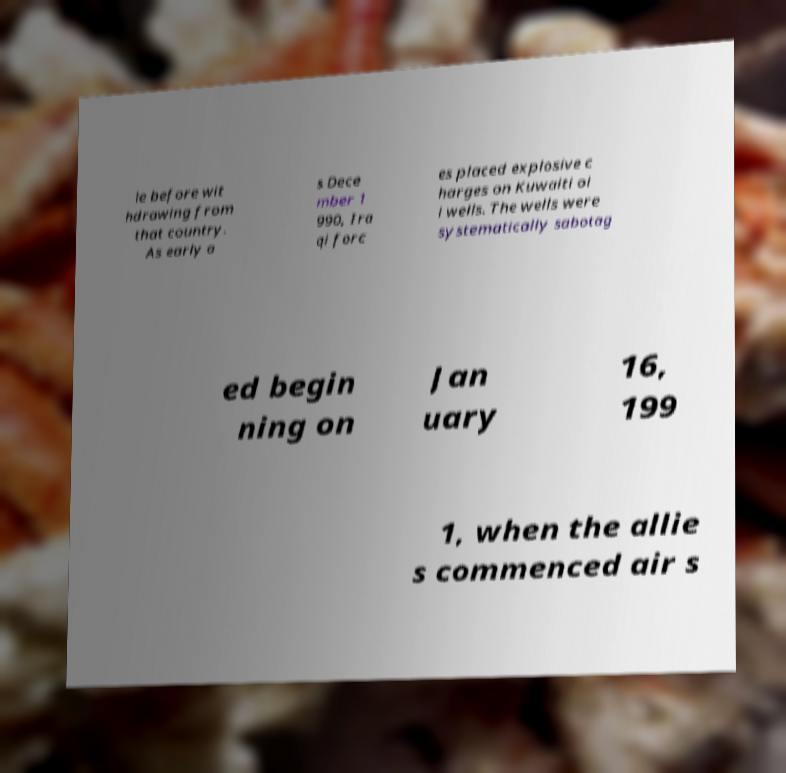There's text embedded in this image that I need extracted. Can you transcribe it verbatim? le before wit hdrawing from that country. As early a s Dece mber 1 990, Ira qi forc es placed explosive c harges on Kuwaiti oi l wells. The wells were systematically sabotag ed begin ning on Jan uary 16, 199 1, when the allie s commenced air s 